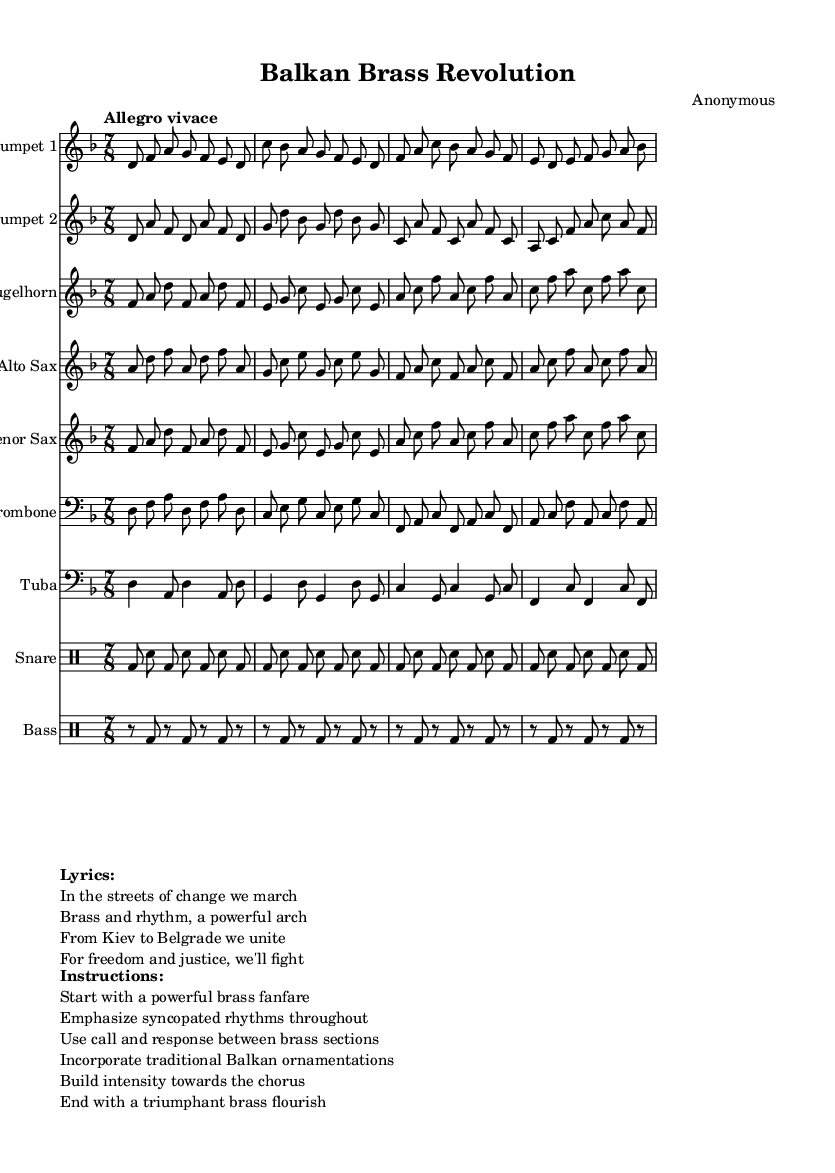What is the key signature of this music? The key signature is D minor, which has one flat (B flat). In the sheet music, the key is indicated after the global variable settings, which specify the key as D minor.
Answer: D minor What is the time signature of this music? The time signature is 7/8, which means there are seven eighth notes in each measure. This is shown in the global section of the score where the time is specified.
Answer: 7/8 What is the tempo marking? The tempo marking is "Allegro vivace," indicating a lively and fast pace. This is part of the global settings in the sheet music.
Answer: Allegro vivace Which instruments are featured in this piece? The instruments featured include Trumpet 1, Trumpet 2, Flugelhorn, Alto Sax, Tenor Sax, Trombone, and Tuba, along with snare and bass drums. Each instrument is noted in the staves at the beginning of each section.
Answer: Trumpet 1, Trumpet 2, Flugelhorn, Alto Sax, Tenor Sax, Trombone, Tuba How many beats are in each measure? There are 7 beats in each measure due to the 7/8 time signature. Each measure accommodates seven eighth notes, confirming that each measure contains seven beats.
Answer: 7 What musical elements are emphasized in the instructions? The instructions emphasize a powerful brass fanfare, syncopated rhythms, call and response between sections, traditional Balkan ornamentations, and building intensity towards the chorus, followed by a triumphant brass flourish. These instructions are listed in the markup section, highlighting specific performance techniques.
Answer: Powerful brass fanfare, syncopated rhythms, call and response, Balkan ornamentations, intensity What themes are reflected in the lyrics? The lyrics reflect themes of unity, freedom, and resistance, suggesting a motivational and political context. Each line of the lyrics emphasizes a call to action, resonating with the idea of marching for justice, which is relevant given the description of the music's political undertones.
Answer: Unity, freedom, resistance 